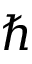Convert formula to latex. <formula><loc_0><loc_0><loc_500><loc_500>\hbar</formula> 